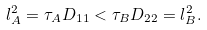<formula> <loc_0><loc_0><loc_500><loc_500>l _ { A } ^ { 2 } = \tau _ { A } D _ { 1 1 } < \tau _ { B } D _ { 2 2 } = l _ { B } ^ { 2 } .</formula> 